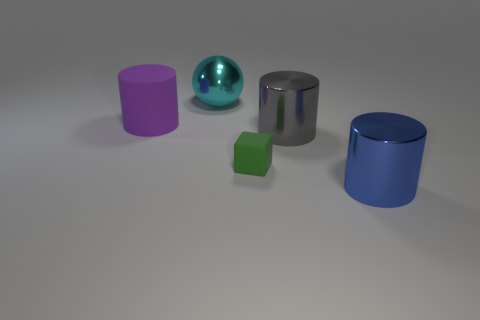Add 1 big cyan spheres. How many objects exist? 6 Subtract all cubes. How many objects are left? 4 Subtract all small green rubber blocks. Subtract all large spheres. How many objects are left? 3 Add 5 big purple cylinders. How many big purple cylinders are left? 6 Add 5 green rubber cubes. How many green rubber cubes exist? 6 Subtract 0 blue blocks. How many objects are left? 5 